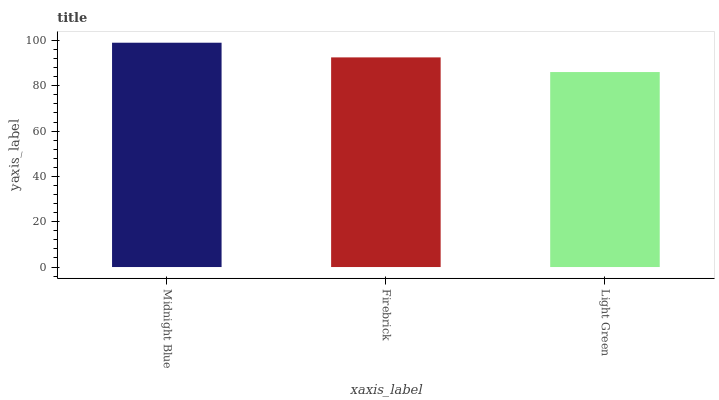Is Light Green the minimum?
Answer yes or no. Yes. Is Midnight Blue the maximum?
Answer yes or no. Yes. Is Firebrick the minimum?
Answer yes or no. No. Is Firebrick the maximum?
Answer yes or no. No. Is Midnight Blue greater than Firebrick?
Answer yes or no. Yes. Is Firebrick less than Midnight Blue?
Answer yes or no. Yes. Is Firebrick greater than Midnight Blue?
Answer yes or no. No. Is Midnight Blue less than Firebrick?
Answer yes or no. No. Is Firebrick the high median?
Answer yes or no. Yes. Is Firebrick the low median?
Answer yes or no. Yes. Is Light Green the high median?
Answer yes or no. No. Is Midnight Blue the low median?
Answer yes or no. No. 